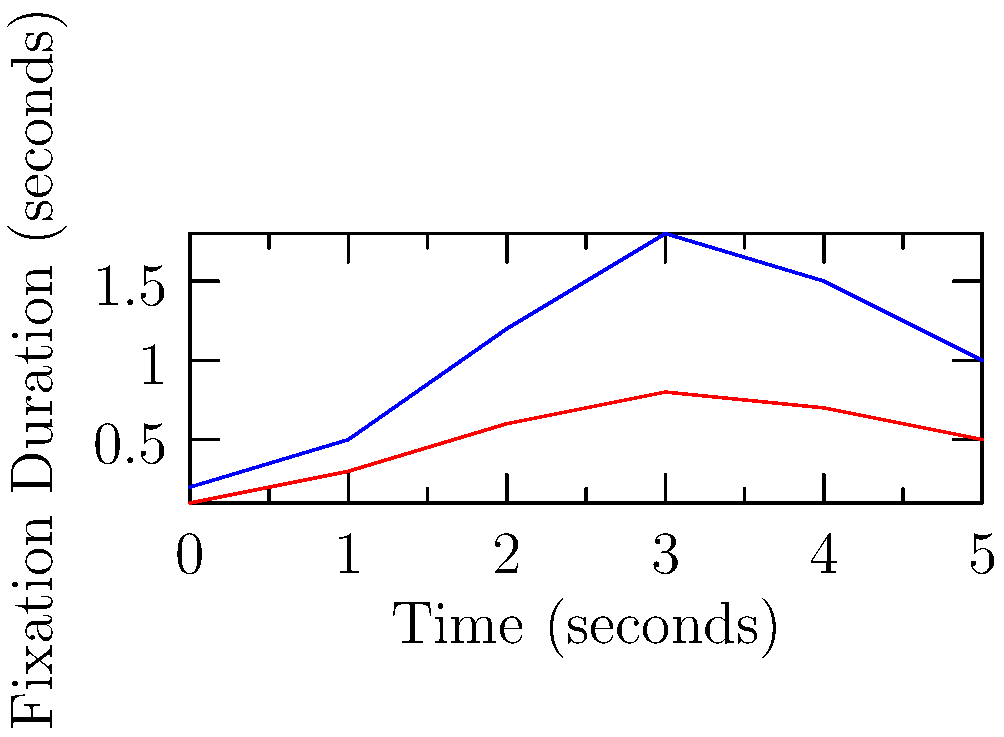Based on the eye-tracking data presented in the graph, which cognitive process might explain the difference in fixation durations between satirical and non-satirical comic strips, and how does this relate to the comprehension of satire? To answer this question, we need to analyze the graph and apply our knowledge of cognitive psychology and satire comprehension:

1. Observe the graph: The blue line (satirical) shows consistently higher fixation durations compared to the red line (non-satirical) across all time points.

2. Interpret fixation duration: Longer fixation durations generally indicate increased cognitive processing or attention.

3. Consider the nature of satire: Satire often involves complex, multi-layered meanings that require more cognitive effort to understand.

4. Apply cognitive theory: The Elaboration Likelihood Model suggests that more effortful processing leads to deeper engagement with content.

5. Relate to satire comprehension: The increased fixation durations for satirical comics likely reflect:
   a) The need to identify incongruities between the literal and intended meanings
   b) The process of resolving these incongruities
   c) The integration of contextual information to grasp the satirical intent

6. Consider the cognitive process: This pattern suggests that understanding satire involves more effortful cognitive elaboration, possibly engaging areas of the brain associated with higher-order thinking, such as the prefrontal cortex.

7. Relate to research methods: This eye-tracking data provides quantitative evidence for the increased cognitive load associated with processing satirical content, supporting theories about the cognitive complexity of satire comprehension.
Answer: Cognitive elaboration process, reflecting the increased mental effort required to identify, resolve, and integrate incongruities in satirical content. 